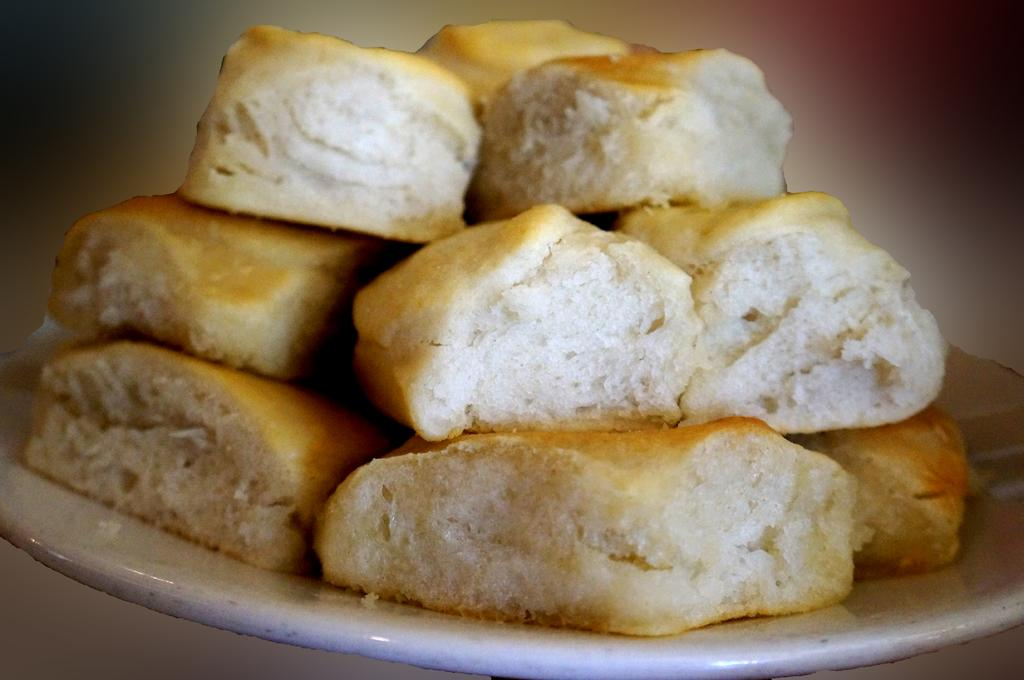What is the main object in the center of the image? There is a plate in the center of the image. What is on the plate? The plate contains bread. What type of industry is depicted in the image? There is no industry depicted in the image; it only contains a plate with bread. What property is shown in the image? There is no property shown in the image; it only contains a plate with bread. 